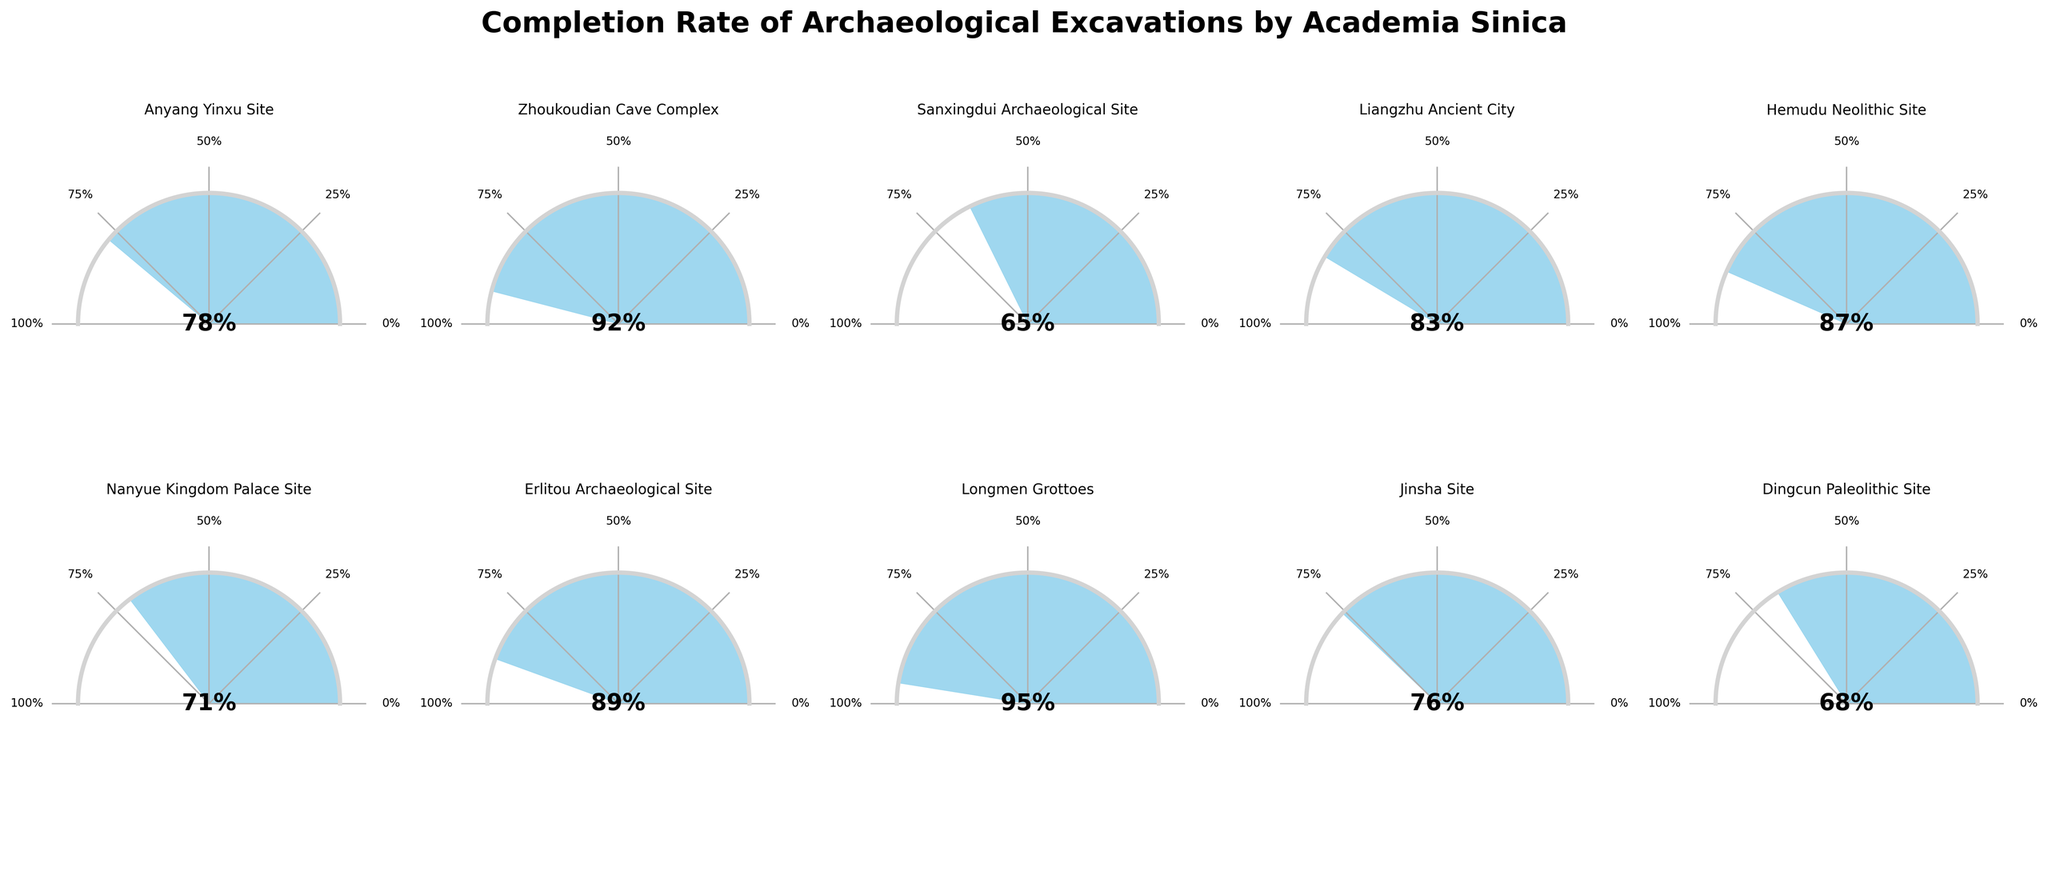What's the title of the figure? The title of the figure is placed at the top and reads "Completion Rate of Archaeological Excavations by Academia Sinica".
Answer: Completion Rate of Archaeological Excavations by Academia Sinica How many excavation sites are shown in the figure? There are 2 rows by 5 columns of gauge charts, making a total of 10 excavation sites displayed.
Answer: 10 Which archaeological excavation site has the highest completion rate? By looking at the filled arc in the polar plots, the Longmen Grottoes has the highest completion rate compared to the others.
Answer: Longmen Grottoes What is the completion percentage at the Nanyue Kingdom Palace Site? Each polar gauge shows the percentage in the center, for the Nanyue Kingdom Palace Site it is 71%.
Answer: 71% Which sites have completion rates above 85%? By examining each polar gauge, the sites with completion rates above 85% are Zhoukoudian Cave Complex, Hemudu Neolithic Site, Erlitou Archaeological Site, and Longmen Grottoes.
Answer: Zhoukoudian Cave Complex, Hemudu Neolithic Site, Erlitou Archaeological Site, Longmen Grottoes What is the difference in completion percentage between the Sanxingdui Archaeological Site and the Jinsha Site? The Sanxingdui site's completion rate is 65%, and the Jinsha site's rate is 76%. Subtracting these gives 76% - 65% = 11%.
Answer: 11% What is the average completion rate of the archaeological excavation sites? Add all completion rates (78, 92, 65, 83, 87, 71, 89, 95, 76, 68) and divide by the number of sites (10). The sum is 804, so the average is 804 / 10 = 80.4%.
Answer: 80.4% How does the completion rate of Hemudu Neolithic Site compare to that of the Anyang Yinxu Site? The Hemudu Neolithic Site has a completion rate of 87%, while the Anyang Yinxu Site has 78%. Comparing these shows that Hemudu Neolithic Site has a higher rate.
Answer: Higher What is the median completion rate among the 10 excavation sites? Arrange the completion rates in ascending order (65, 68, 71, 76, 78, 83, 87, 89, 92, 95). The median is the average of the 5th and 6th values: (78 + 83) / 2 = 80.5%.
Answer: 80.5% What are the names of the sites with completion rates between 70% and 80%? From the gauges, the sites in the 70% to 80% range are Anyang Yinxu Site (78%), Nanyue Kingdom Palace Site (71%), Jinsha Site (76%).
Answer: Anyang Yinxu Site, Nanyue Kingdom Palace Site, Jinsha Site 